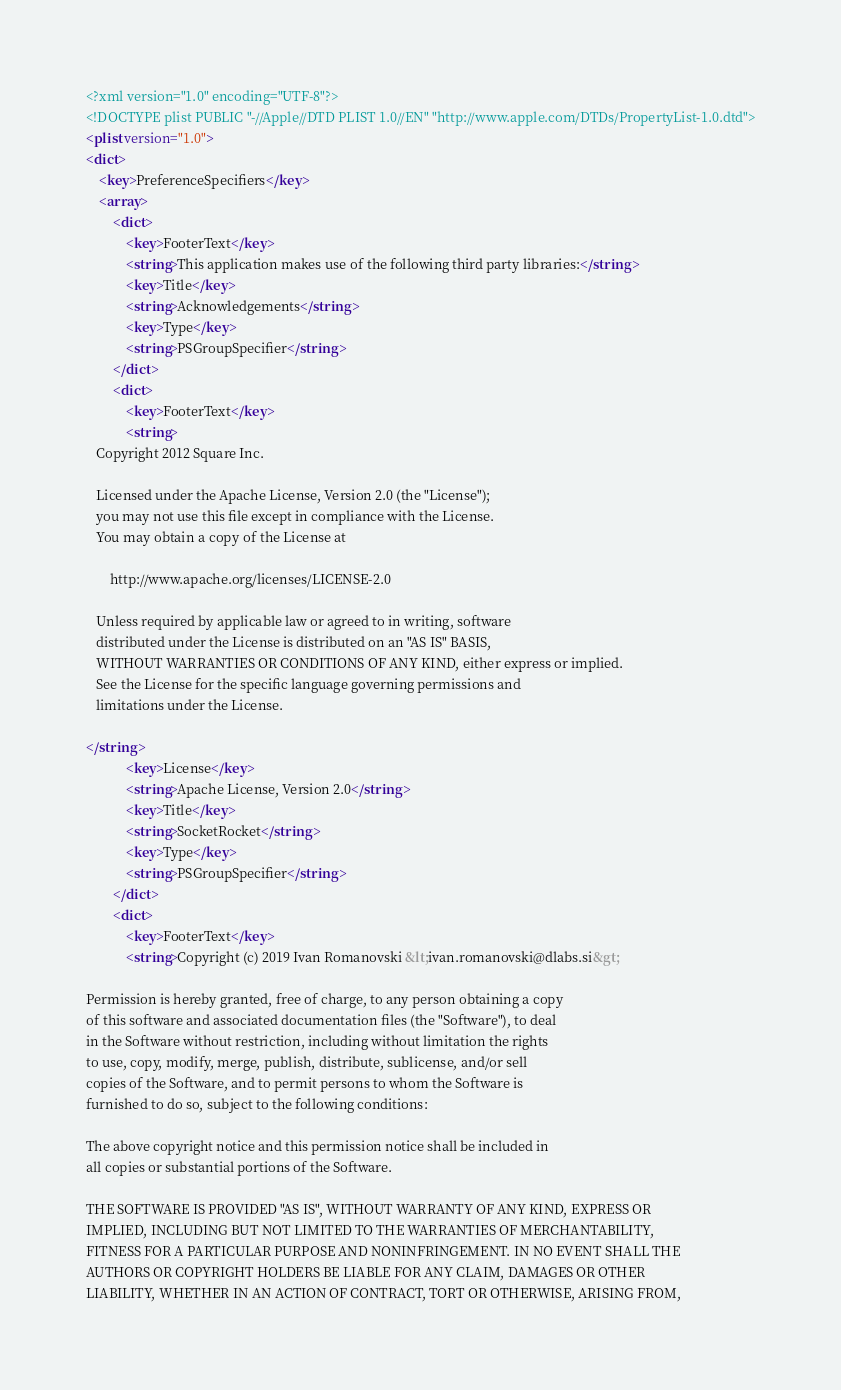<code> <loc_0><loc_0><loc_500><loc_500><_XML_><?xml version="1.0" encoding="UTF-8"?>
<!DOCTYPE plist PUBLIC "-//Apple//DTD PLIST 1.0//EN" "http://www.apple.com/DTDs/PropertyList-1.0.dtd">
<plist version="1.0">
<dict>
	<key>PreferenceSpecifiers</key>
	<array>
		<dict>
			<key>FooterText</key>
			<string>This application makes use of the following third party libraries:</string>
			<key>Title</key>
			<string>Acknowledgements</string>
			<key>Type</key>
			<string>PSGroupSpecifier</string>
		</dict>
		<dict>
			<key>FooterText</key>
			<string>
   Copyright 2012 Square Inc.

   Licensed under the Apache License, Version 2.0 (the "License");
   you may not use this file except in compliance with the License.
   You may obtain a copy of the License at

       http://www.apache.org/licenses/LICENSE-2.0

   Unless required by applicable law or agreed to in writing, software
   distributed under the License is distributed on an "AS IS" BASIS,
   WITHOUT WARRANTIES OR CONDITIONS OF ANY KIND, either express or implied.
   See the License for the specific language governing permissions and
   limitations under the License.

</string>
			<key>License</key>
			<string>Apache License, Version 2.0</string>
			<key>Title</key>
			<string>SocketRocket</string>
			<key>Type</key>
			<string>PSGroupSpecifier</string>
		</dict>
		<dict>
			<key>FooterText</key>
			<string>Copyright (c) 2019 Ivan Romanovski &lt;ivan.romanovski@dlabs.si&gt;

Permission is hereby granted, free of charge, to any person obtaining a copy
of this software and associated documentation files (the "Software"), to deal
in the Software without restriction, including without limitation the rights
to use, copy, modify, merge, publish, distribute, sublicense, and/or sell
copies of the Software, and to permit persons to whom the Software is
furnished to do so, subject to the following conditions:

The above copyright notice and this permission notice shall be included in
all copies or substantial portions of the Software.

THE SOFTWARE IS PROVIDED "AS IS", WITHOUT WARRANTY OF ANY KIND, EXPRESS OR
IMPLIED, INCLUDING BUT NOT LIMITED TO THE WARRANTIES OF MERCHANTABILITY,
FITNESS FOR A PARTICULAR PURPOSE AND NONINFRINGEMENT. IN NO EVENT SHALL THE
AUTHORS OR COPYRIGHT HOLDERS BE LIABLE FOR ANY CLAIM, DAMAGES OR OTHER
LIABILITY, WHETHER IN AN ACTION OF CONTRACT, TORT OR OTHERWISE, ARISING FROM,</code> 